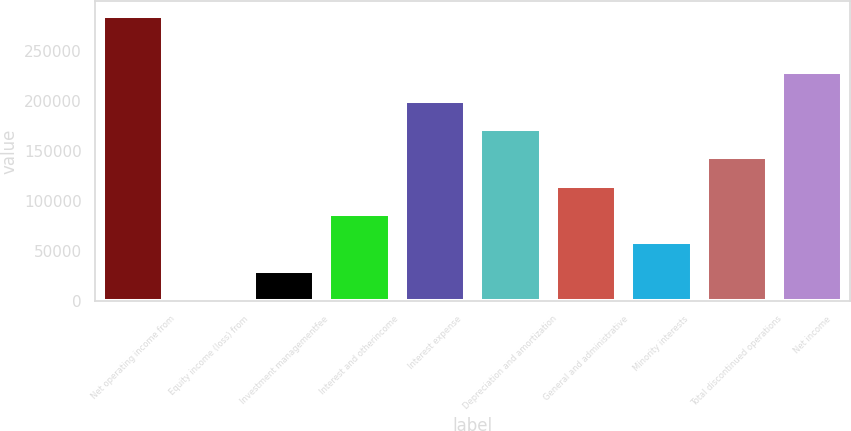<chart> <loc_0><loc_0><loc_500><loc_500><bar_chart><fcel>Net operating income from<fcel>Equity income (loss) from<fcel>Investment managementfee<fcel>Interest and otherincome<fcel>Interest expense<fcel>Depreciation and amortization<fcel>General and administrative<fcel>Minority interests<fcel>Total discontinued operations<fcel>Net income<nl><fcel>285410<fcel>2157<fcel>30482.3<fcel>87132.9<fcel>200434<fcel>172109<fcel>115458<fcel>58807.6<fcel>143784<fcel>228759<nl></chart> 